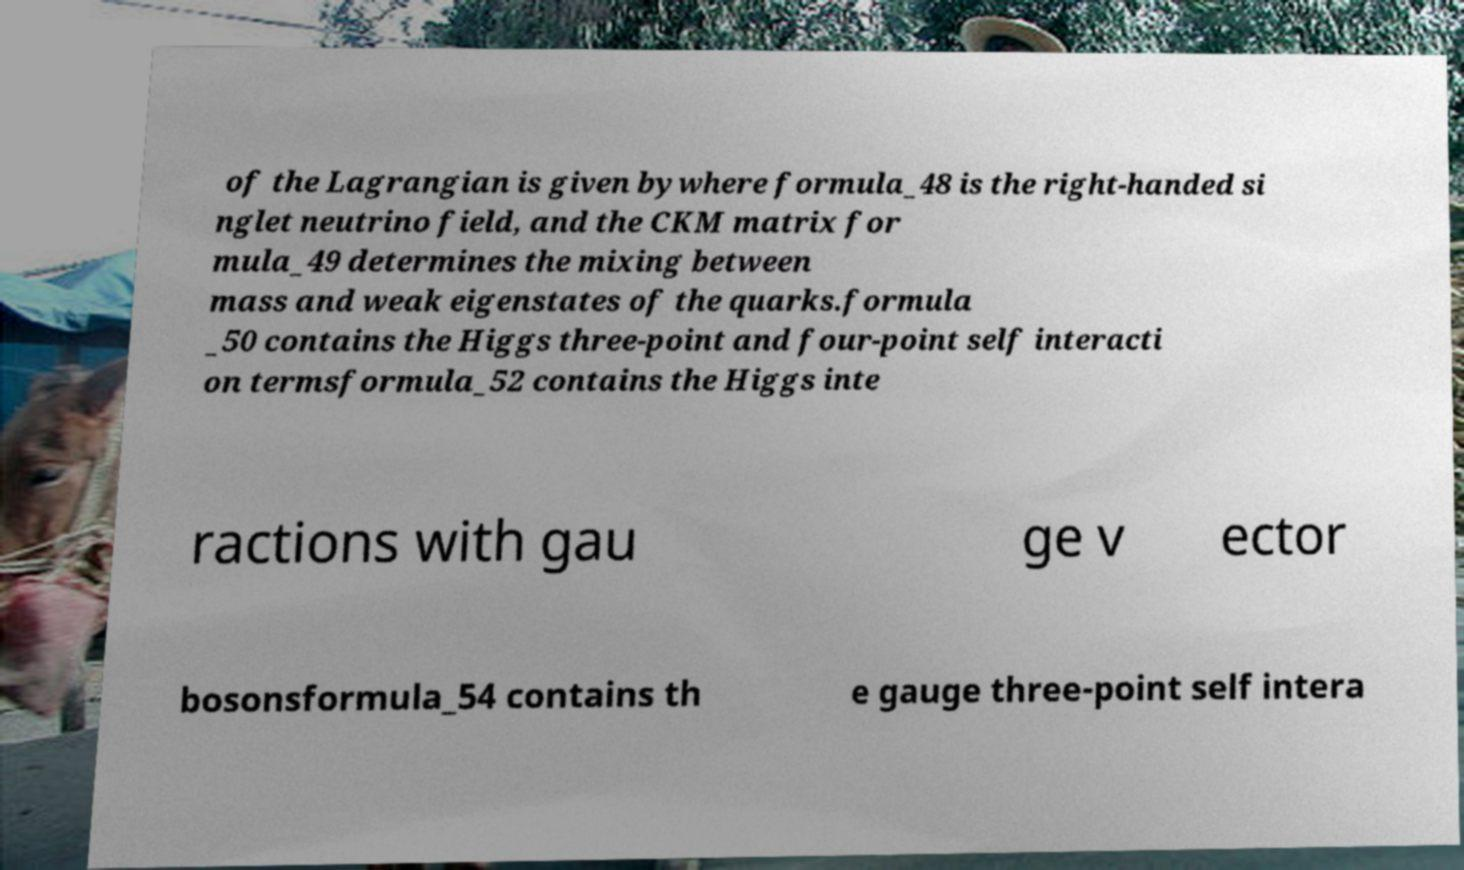Could you extract and type out the text from this image? of the Lagrangian is given bywhere formula_48 is the right-handed si nglet neutrino field, and the CKM matrix for mula_49 determines the mixing between mass and weak eigenstates of the quarks.formula _50 contains the Higgs three-point and four-point self interacti on termsformula_52 contains the Higgs inte ractions with gau ge v ector bosonsformula_54 contains th e gauge three-point self intera 